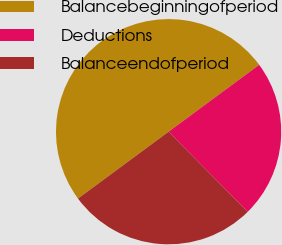Convert chart. <chart><loc_0><loc_0><loc_500><loc_500><pie_chart><fcel>Balancebeginningofperiod<fcel>Deductions<fcel>Balanceendofperiod<nl><fcel>50.0%<fcel>22.73%<fcel>27.27%<nl></chart> 